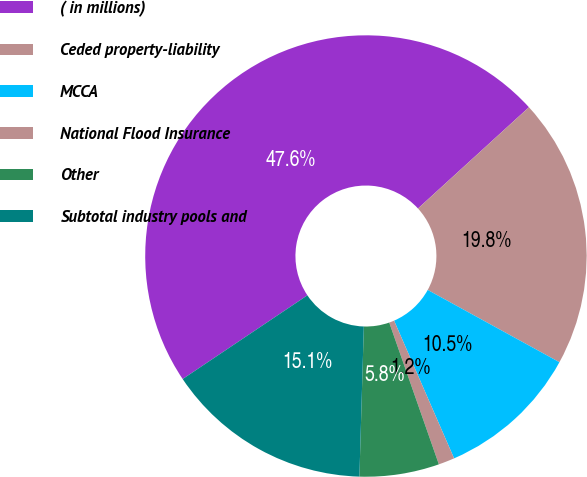Convert chart to OTSL. <chart><loc_0><loc_0><loc_500><loc_500><pie_chart><fcel>( in millions)<fcel>Ceded property-liability<fcel>MCCA<fcel>National Flood Insurance<fcel>Other<fcel>Subtotal industry pools and<nl><fcel>47.63%<fcel>19.76%<fcel>10.47%<fcel>1.18%<fcel>5.83%<fcel>15.12%<nl></chart> 